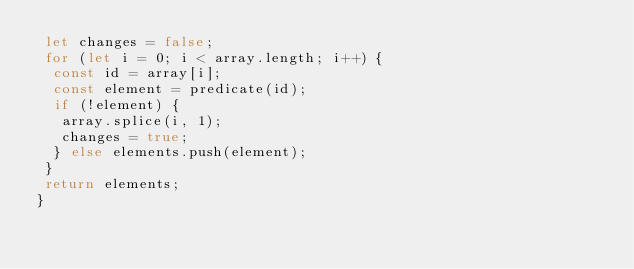Convert code to text. <code><loc_0><loc_0><loc_500><loc_500><_TypeScript_> let changes = false;
 for (let i = 0; i < array.length; i++) {
  const id = array[i];
  const element = predicate(id);
  if (!element) {
   array.splice(i, 1);
   changes = true;
  } else elements.push(element);
 }
 return elements;
}</code> 